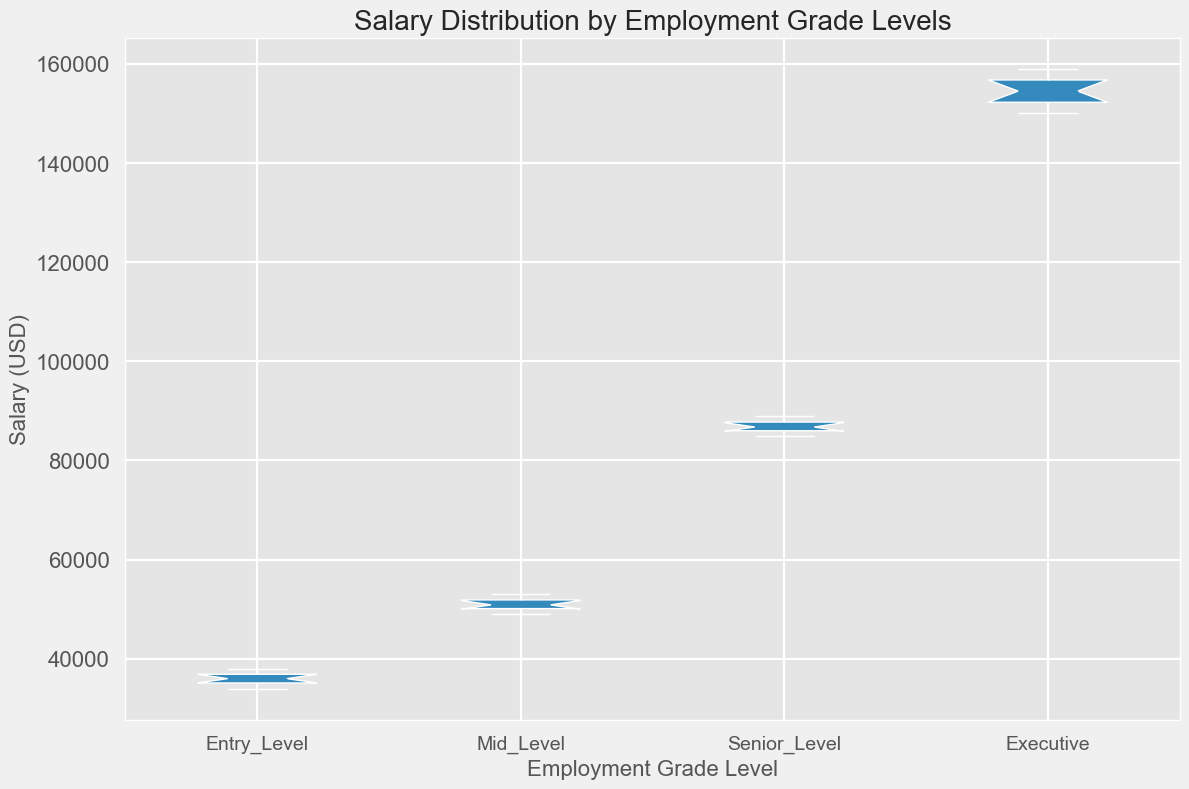What is the median salary for the Executive employment grade? To determine the median salary, locate the middle value when the salaries are arranged in ascending order. For Executives, salaries are: [150000, 151000, 152000, 153000, 154000, 155000, 156000, 157000, 158000, 159000]. The median is the average of the 5th and 6th values: (154000 + 155000)/2 = 154500.
Answer: 154500 What is the interquartile range (IQR) of salaries for the Mid-Level employment grade? The interquartile range is the difference between the third quartile (Q3) and the first quartile (Q1). For Mid-Level, sort the salaries: [49000, 49500, 50000, 50500, 50750, 51000, 51500, 52000, 52500, 53000]. Q1 is the 3rd value (50500), and Q3 is the 8th value (52000). IQR = Q3 - Q1 = 52000 - 50500 = 1500.
Answer: 1500 Which employment grade has the highest median salary? Compare the median salaries of all employment grades shown as the central horizontal line within each box. The Executive grade has the highest visible median salary.
Answer: Executive Is the salary range in Senior-Level broader than Mid-Level? Salary range is defined by the distance between the minimum and maximum values in the box plot. Comparing the vertical extents, the range for Senior-Level (approximately 85000 to 89000) appears broader than Mid-Level (approximately 49000 to 53000).
Answer: Yes Which employment grade shows the most consistent salary distribution? Consistency in salary distribution is indicated by the shortest box length (smallest interquartile range). From visual inspection, the Mid-Level grade has the shortest box, indicating the most consistent distribution.
Answer: Mid-Level Which employment grade has the widest salary range? The widest salary range is indicated by the longest distance from the lowest whisker to the highest whisker. From the figure, the Executive grade shows the widest range (approximately 150000 to 159000).
Answer: Executive How does the median salary of Entry-Level compare to that of Senior-Level? The median salary for Entry-Level is the central value displayed in its box (approximately 36000), whereas for Senior-Level it is around 86500. The Senior-Level median salary is significantly higher than that of Entry-Level.
Answer: Senior-Level is higher What is the approximate difference between the maximum salary of Entry-Level and the minimum salary of Executive? The maximum salary of Entry-Level, shown by the highest whisker, is about 38000. The minimum salary of Executive, indicated by the lowest whisker, is approximately 150000. Difference = 150000 - 38000 = 112000.
Answer: 112000 